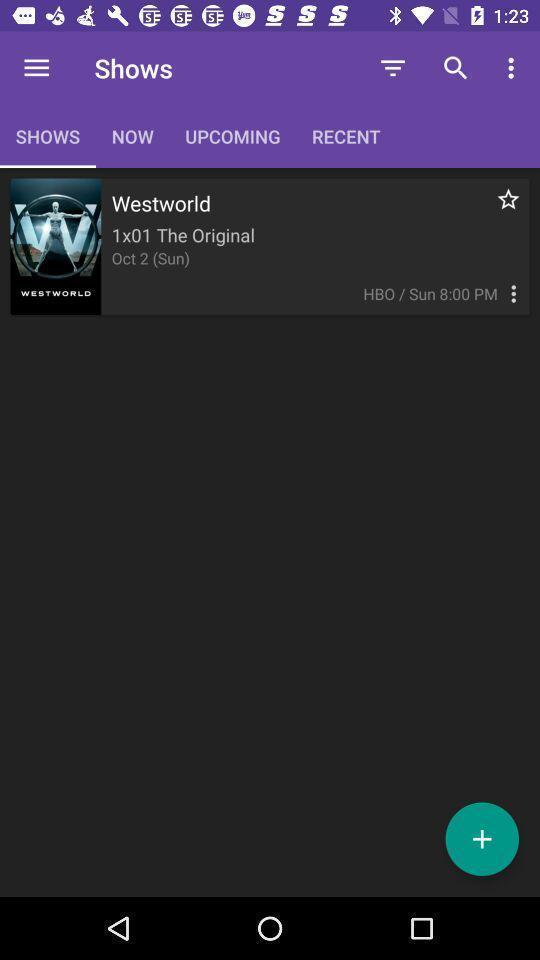Explain what's happening in this screen capture. Page to find the movies and episodes. 